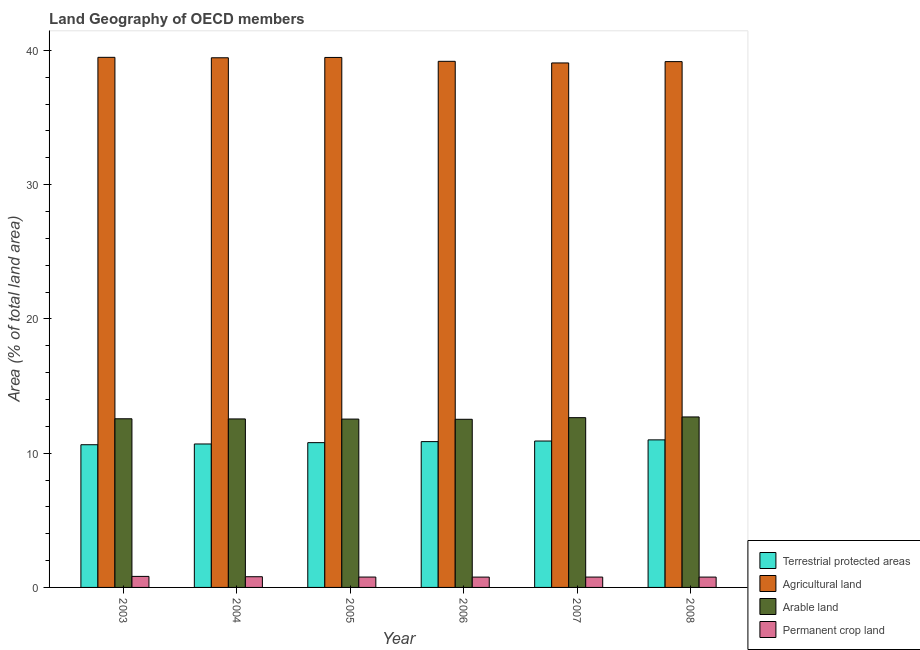Are the number of bars on each tick of the X-axis equal?
Provide a succinct answer. Yes. How many bars are there on the 6th tick from the right?
Provide a short and direct response. 4. What is the label of the 3rd group of bars from the left?
Your answer should be compact. 2005. What is the percentage of area under agricultural land in 2003?
Make the answer very short. 39.48. Across all years, what is the maximum percentage of area under permanent crop land?
Offer a very short reply. 0.82. Across all years, what is the minimum percentage of land under terrestrial protection?
Provide a short and direct response. 10.63. In which year was the percentage of land under terrestrial protection minimum?
Keep it short and to the point. 2003. What is the total percentage of area under arable land in the graph?
Keep it short and to the point. 75.51. What is the difference between the percentage of area under permanent crop land in 2006 and that in 2007?
Offer a very short reply. -0. What is the difference between the percentage of area under agricultural land in 2005 and the percentage of area under permanent crop land in 2003?
Your answer should be very brief. -0.01. What is the average percentage of area under agricultural land per year?
Offer a very short reply. 39.3. In the year 2005, what is the difference between the percentage of area under agricultural land and percentage of land under terrestrial protection?
Your answer should be compact. 0. What is the ratio of the percentage of area under agricultural land in 2003 to that in 2004?
Give a very brief answer. 1. Is the difference between the percentage of land under terrestrial protection in 2005 and 2007 greater than the difference between the percentage of area under arable land in 2005 and 2007?
Your response must be concise. No. What is the difference between the highest and the second highest percentage of area under permanent crop land?
Offer a very short reply. 0.02. What is the difference between the highest and the lowest percentage of land under terrestrial protection?
Your response must be concise. 0.36. Is it the case that in every year, the sum of the percentage of area under permanent crop land and percentage of area under arable land is greater than the sum of percentage of land under terrestrial protection and percentage of area under agricultural land?
Offer a very short reply. No. What does the 3rd bar from the left in 2003 represents?
Ensure brevity in your answer.  Arable land. What does the 4th bar from the right in 2005 represents?
Keep it short and to the point. Terrestrial protected areas. Where does the legend appear in the graph?
Provide a short and direct response. Bottom right. What is the title of the graph?
Provide a succinct answer. Land Geography of OECD members. Does "Methodology assessment" appear as one of the legend labels in the graph?
Provide a short and direct response. No. What is the label or title of the X-axis?
Offer a terse response. Year. What is the label or title of the Y-axis?
Your response must be concise. Area (% of total land area). What is the Area (% of total land area) of Terrestrial protected areas in 2003?
Make the answer very short. 10.63. What is the Area (% of total land area) in Agricultural land in 2003?
Offer a very short reply. 39.48. What is the Area (% of total land area) of Arable land in 2003?
Give a very brief answer. 12.56. What is the Area (% of total land area) of Permanent crop land in 2003?
Make the answer very short. 0.82. What is the Area (% of total land area) of Terrestrial protected areas in 2004?
Offer a very short reply. 10.68. What is the Area (% of total land area) of Agricultural land in 2004?
Ensure brevity in your answer.  39.45. What is the Area (% of total land area) in Arable land in 2004?
Offer a very short reply. 12.55. What is the Area (% of total land area) of Permanent crop land in 2004?
Offer a very short reply. 0.8. What is the Area (% of total land area) in Terrestrial protected areas in 2005?
Ensure brevity in your answer.  10.78. What is the Area (% of total land area) of Agricultural land in 2005?
Provide a short and direct response. 39.47. What is the Area (% of total land area) in Arable land in 2005?
Provide a short and direct response. 12.54. What is the Area (% of total land area) of Permanent crop land in 2005?
Provide a short and direct response. 0.77. What is the Area (% of total land area) of Terrestrial protected areas in 2006?
Your response must be concise. 10.86. What is the Area (% of total land area) of Agricultural land in 2006?
Give a very brief answer. 39.18. What is the Area (% of total land area) of Arable land in 2006?
Offer a very short reply. 12.52. What is the Area (% of total land area) in Permanent crop land in 2006?
Your answer should be compact. 0.77. What is the Area (% of total land area) in Terrestrial protected areas in 2007?
Offer a terse response. 10.9. What is the Area (% of total land area) of Agricultural land in 2007?
Your answer should be very brief. 39.06. What is the Area (% of total land area) in Arable land in 2007?
Your response must be concise. 12.64. What is the Area (% of total land area) of Permanent crop land in 2007?
Make the answer very short. 0.77. What is the Area (% of total land area) of Terrestrial protected areas in 2008?
Keep it short and to the point. 10.99. What is the Area (% of total land area) of Agricultural land in 2008?
Keep it short and to the point. 39.16. What is the Area (% of total land area) of Arable land in 2008?
Your answer should be compact. 12.7. What is the Area (% of total land area) of Permanent crop land in 2008?
Offer a very short reply. 0.77. Across all years, what is the maximum Area (% of total land area) in Terrestrial protected areas?
Keep it short and to the point. 10.99. Across all years, what is the maximum Area (% of total land area) of Agricultural land?
Provide a succinct answer. 39.48. Across all years, what is the maximum Area (% of total land area) in Arable land?
Give a very brief answer. 12.7. Across all years, what is the maximum Area (% of total land area) of Permanent crop land?
Give a very brief answer. 0.82. Across all years, what is the minimum Area (% of total land area) in Terrestrial protected areas?
Offer a terse response. 10.63. Across all years, what is the minimum Area (% of total land area) in Agricultural land?
Give a very brief answer. 39.06. Across all years, what is the minimum Area (% of total land area) of Arable land?
Your answer should be compact. 12.52. Across all years, what is the minimum Area (% of total land area) of Permanent crop land?
Provide a short and direct response. 0.77. What is the total Area (% of total land area) in Terrestrial protected areas in the graph?
Keep it short and to the point. 64.85. What is the total Area (% of total land area) of Agricultural land in the graph?
Ensure brevity in your answer.  235.81. What is the total Area (% of total land area) of Arable land in the graph?
Give a very brief answer. 75.51. What is the total Area (% of total land area) in Permanent crop land in the graph?
Keep it short and to the point. 4.7. What is the difference between the Area (% of total land area) in Terrestrial protected areas in 2003 and that in 2004?
Your response must be concise. -0.06. What is the difference between the Area (% of total land area) of Agricultural land in 2003 and that in 2004?
Provide a succinct answer. 0.03. What is the difference between the Area (% of total land area) in Arable land in 2003 and that in 2004?
Your answer should be compact. 0.01. What is the difference between the Area (% of total land area) of Permanent crop land in 2003 and that in 2004?
Offer a terse response. 0.02. What is the difference between the Area (% of total land area) of Terrestrial protected areas in 2003 and that in 2005?
Your answer should be compact. -0.16. What is the difference between the Area (% of total land area) of Agricultural land in 2003 and that in 2005?
Give a very brief answer. 0.01. What is the difference between the Area (% of total land area) in Arable land in 2003 and that in 2005?
Your answer should be very brief. 0.02. What is the difference between the Area (% of total land area) in Permanent crop land in 2003 and that in 2005?
Provide a succinct answer. 0.05. What is the difference between the Area (% of total land area) in Terrestrial protected areas in 2003 and that in 2006?
Give a very brief answer. -0.23. What is the difference between the Area (% of total land area) of Agricultural land in 2003 and that in 2006?
Your response must be concise. 0.3. What is the difference between the Area (% of total land area) of Arable land in 2003 and that in 2006?
Provide a succinct answer. 0.04. What is the difference between the Area (% of total land area) of Permanent crop land in 2003 and that in 2006?
Keep it short and to the point. 0.05. What is the difference between the Area (% of total land area) of Terrestrial protected areas in 2003 and that in 2007?
Provide a short and direct response. -0.28. What is the difference between the Area (% of total land area) of Agricultural land in 2003 and that in 2007?
Ensure brevity in your answer.  0.42. What is the difference between the Area (% of total land area) in Arable land in 2003 and that in 2007?
Make the answer very short. -0.08. What is the difference between the Area (% of total land area) in Permanent crop land in 2003 and that in 2007?
Offer a terse response. 0.05. What is the difference between the Area (% of total land area) in Terrestrial protected areas in 2003 and that in 2008?
Provide a succinct answer. -0.36. What is the difference between the Area (% of total land area) of Agricultural land in 2003 and that in 2008?
Your response must be concise. 0.32. What is the difference between the Area (% of total land area) of Arable land in 2003 and that in 2008?
Your answer should be very brief. -0.14. What is the difference between the Area (% of total land area) of Permanent crop land in 2003 and that in 2008?
Offer a very short reply. 0.05. What is the difference between the Area (% of total land area) of Terrestrial protected areas in 2004 and that in 2005?
Ensure brevity in your answer.  -0.1. What is the difference between the Area (% of total land area) of Agricultural land in 2004 and that in 2005?
Keep it short and to the point. -0.02. What is the difference between the Area (% of total land area) in Arable land in 2004 and that in 2005?
Provide a short and direct response. 0.01. What is the difference between the Area (% of total land area) of Permanent crop land in 2004 and that in 2005?
Your response must be concise. 0.02. What is the difference between the Area (% of total land area) of Terrestrial protected areas in 2004 and that in 2006?
Offer a terse response. -0.18. What is the difference between the Area (% of total land area) in Agricultural land in 2004 and that in 2006?
Make the answer very short. 0.26. What is the difference between the Area (% of total land area) of Arable land in 2004 and that in 2006?
Offer a very short reply. 0.03. What is the difference between the Area (% of total land area) of Permanent crop land in 2004 and that in 2006?
Your response must be concise. 0.03. What is the difference between the Area (% of total land area) of Terrestrial protected areas in 2004 and that in 2007?
Provide a succinct answer. -0.22. What is the difference between the Area (% of total land area) of Agricultural land in 2004 and that in 2007?
Make the answer very short. 0.38. What is the difference between the Area (% of total land area) in Arable land in 2004 and that in 2007?
Your response must be concise. -0.09. What is the difference between the Area (% of total land area) of Permanent crop land in 2004 and that in 2007?
Your answer should be very brief. 0.03. What is the difference between the Area (% of total land area) of Terrestrial protected areas in 2004 and that in 2008?
Offer a very short reply. -0.31. What is the difference between the Area (% of total land area) in Agricultural land in 2004 and that in 2008?
Give a very brief answer. 0.29. What is the difference between the Area (% of total land area) in Arable land in 2004 and that in 2008?
Give a very brief answer. -0.15. What is the difference between the Area (% of total land area) in Permanent crop land in 2004 and that in 2008?
Your answer should be very brief. 0.03. What is the difference between the Area (% of total land area) in Terrestrial protected areas in 2005 and that in 2006?
Provide a short and direct response. -0.08. What is the difference between the Area (% of total land area) of Agricultural land in 2005 and that in 2006?
Provide a succinct answer. 0.29. What is the difference between the Area (% of total land area) of Arable land in 2005 and that in 2006?
Offer a very short reply. 0.01. What is the difference between the Area (% of total land area) of Permanent crop land in 2005 and that in 2006?
Provide a short and direct response. 0. What is the difference between the Area (% of total land area) of Terrestrial protected areas in 2005 and that in 2007?
Keep it short and to the point. -0.12. What is the difference between the Area (% of total land area) in Agricultural land in 2005 and that in 2007?
Provide a succinct answer. 0.41. What is the difference between the Area (% of total land area) in Arable land in 2005 and that in 2007?
Make the answer very short. -0.11. What is the difference between the Area (% of total land area) of Permanent crop land in 2005 and that in 2007?
Give a very brief answer. 0. What is the difference between the Area (% of total land area) of Terrestrial protected areas in 2005 and that in 2008?
Your response must be concise. -0.21. What is the difference between the Area (% of total land area) in Agricultural land in 2005 and that in 2008?
Make the answer very short. 0.31. What is the difference between the Area (% of total land area) of Arable land in 2005 and that in 2008?
Ensure brevity in your answer.  -0.16. What is the difference between the Area (% of total land area) in Permanent crop land in 2005 and that in 2008?
Ensure brevity in your answer.  0. What is the difference between the Area (% of total land area) in Terrestrial protected areas in 2006 and that in 2007?
Your response must be concise. -0.04. What is the difference between the Area (% of total land area) of Agricultural land in 2006 and that in 2007?
Provide a succinct answer. 0.12. What is the difference between the Area (% of total land area) of Arable land in 2006 and that in 2007?
Your response must be concise. -0.12. What is the difference between the Area (% of total land area) in Permanent crop land in 2006 and that in 2007?
Your answer should be very brief. -0. What is the difference between the Area (% of total land area) of Terrestrial protected areas in 2006 and that in 2008?
Ensure brevity in your answer.  -0.13. What is the difference between the Area (% of total land area) of Agricultural land in 2006 and that in 2008?
Provide a succinct answer. 0.02. What is the difference between the Area (% of total land area) of Arable land in 2006 and that in 2008?
Your response must be concise. -0.17. What is the difference between the Area (% of total land area) in Permanent crop land in 2006 and that in 2008?
Your answer should be very brief. -0. What is the difference between the Area (% of total land area) of Terrestrial protected areas in 2007 and that in 2008?
Keep it short and to the point. -0.09. What is the difference between the Area (% of total land area) of Agricultural land in 2007 and that in 2008?
Provide a succinct answer. -0.1. What is the difference between the Area (% of total land area) of Arable land in 2007 and that in 2008?
Your answer should be very brief. -0.05. What is the difference between the Area (% of total land area) of Permanent crop land in 2007 and that in 2008?
Provide a short and direct response. 0. What is the difference between the Area (% of total land area) in Terrestrial protected areas in 2003 and the Area (% of total land area) in Agricultural land in 2004?
Make the answer very short. -28.82. What is the difference between the Area (% of total land area) of Terrestrial protected areas in 2003 and the Area (% of total land area) of Arable land in 2004?
Ensure brevity in your answer.  -1.92. What is the difference between the Area (% of total land area) in Terrestrial protected areas in 2003 and the Area (% of total land area) in Permanent crop land in 2004?
Offer a terse response. 9.83. What is the difference between the Area (% of total land area) in Agricultural land in 2003 and the Area (% of total land area) in Arable land in 2004?
Provide a succinct answer. 26.93. What is the difference between the Area (% of total land area) of Agricultural land in 2003 and the Area (% of total land area) of Permanent crop land in 2004?
Provide a short and direct response. 38.68. What is the difference between the Area (% of total land area) of Arable land in 2003 and the Area (% of total land area) of Permanent crop land in 2004?
Your answer should be compact. 11.76. What is the difference between the Area (% of total land area) of Terrestrial protected areas in 2003 and the Area (% of total land area) of Agricultural land in 2005?
Offer a terse response. -28.84. What is the difference between the Area (% of total land area) of Terrestrial protected areas in 2003 and the Area (% of total land area) of Arable land in 2005?
Your response must be concise. -1.91. What is the difference between the Area (% of total land area) in Terrestrial protected areas in 2003 and the Area (% of total land area) in Permanent crop land in 2005?
Provide a short and direct response. 9.86. What is the difference between the Area (% of total land area) in Agricultural land in 2003 and the Area (% of total land area) in Arable land in 2005?
Provide a short and direct response. 26.94. What is the difference between the Area (% of total land area) in Agricultural land in 2003 and the Area (% of total land area) in Permanent crop land in 2005?
Your response must be concise. 38.71. What is the difference between the Area (% of total land area) of Arable land in 2003 and the Area (% of total land area) of Permanent crop land in 2005?
Give a very brief answer. 11.79. What is the difference between the Area (% of total land area) in Terrestrial protected areas in 2003 and the Area (% of total land area) in Agricultural land in 2006?
Offer a very short reply. -28.56. What is the difference between the Area (% of total land area) in Terrestrial protected areas in 2003 and the Area (% of total land area) in Arable land in 2006?
Ensure brevity in your answer.  -1.9. What is the difference between the Area (% of total land area) in Terrestrial protected areas in 2003 and the Area (% of total land area) in Permanent crop land in 2006?
Ensure brevity in your answer.  9.86. What is the difference between the Area (% of total land area) in Agricultural land in 2003 and the Area (% of total land area) in Arable land in 2006?
Your answer should be very brief. 26.96. What is the difference between the Area (% of total land area) of Agricultural land in 2003 and the Area (% of total land area) of Permanent crop land in 2006?
Offer a terse response. 38.71. What is the difference between the Area (% of total land area) of Arable land in 2003 and the Area (% of total land area) of Permanent crop land in 2006?
Ensure brevity in your answer.  11.79. What is the difference between the Area (% of total land area) in Terrestrial protected areas in 2003 and the Area (% of total land area) in Agricultural land in 2007?
Keep it short and to the point. -28.43. What is the difference between the Area (% of total land area) in Terrestrial protected areas in 2003 and the Area (% of total land area) in Arable land in 2007?
Your answer should be compact. -2.02. What is the difference between the Area (% of total land area) in Terrestrial protected areas in 2003 and the Area (% of total land area) in Permanent crop land in 2007?
Keep it short and to the point. 9.86. What is the difference between the Area (% of total land area) of Agricultural land in 2003 and the Area (% of total land area) of Arable land in 2007?
Make the answer very short. 26.84. What is the difference between the Area (% of total land area) of Agricultural land in 2003 and the Area (% of total land area) of Permanent crop land in 2007?
Provide a short and direct response. 38.71. What is the difference between the Area (% of total land area) in Arable land in 2003 and the Area (% of total land area) in Permanent crop land in 2007?
Your answer should be very brief. 11.79. What is the difference between the Area (% of total land area) in Terrestrial protected areas in 2003 and the Area (% of total land area) in Agricultural land in 2008?
Offer a terse response. -28.53. What is the difference between the Area (% of total land area) in Terrestrial protected areas in 2003 and the Area (% of total land area) in Arable land in 2008?
Ensure brevity in your answer.  -2.07. What is the difference between the Area (% of total land area) of Terrestrial protected areas in 2003 and the Area (% of total land area) of Permanent crop land in 2008?
Make the answer very short. 9.86. What is the difference between the Area (% of total land area) of Agricultural land in 2003 and the Area (% of total land area) of Arable land in 2008?
Provide a succinct answer. 26.78. What is the difference between the Area (% of total land area) of Agricultural land in 2003 and the Area (% of total land area) of Permanent crop land in 2008?
Make the answer very short. 38.71. What is the difference between the Area (% of total land area) of Arable land in 2003 and the Area (% of total land area) of Permanent crop land in 2008?
Your response must be concise. 11.79. What is the difference between the Area (% of total land area) of Terrestrial protected areas in 2004 and the Area (% of total land area) of Agricultural land in 2005?
Keep it short and to the point. -28.79. What is the difference between the Area (% of total land area) of Terrestrial protected areas in 2004 and the Area (% of total land area) of Arable land in 2005?
Ensure brevity in your answer.  -1.85. What is the difference between the Area (% of total land area) of Terrestrial protected areas in 2004 and the Area (% of total land area) of Permanent crop land in 2005?
Give a very brief answer. 9.91. What is the difference between the Area (% of total land area) in Agricultural land in 2004 and the Area (% of total land area) in Arable land in 2005?
Your answer should be compact. 26.91. What is the difference between the Area (% of total land area) of Agricultural land in 2004 and the Area (% of total land area) of Permanent crop land in 2005?
Offer a terse response. 38.68. What is the difference between the Area (% of total land area) in Arable land in 2004 and the Area (% of total land area) in Permanent crop land in 2005?
Keep it short and to the point. 11.78. What is the difference between the Area (% of total land area) of Terrestrial protected areas in 2004 and the Area (% of total land area) of Agricultural land in 2006?
Offer a terse response. -28.5. What is the difference between the Area (% of total land area) in Terrestrial protected areas in 2004 and the Area (% of total land area) in Arable land in 2006?
Offer a very short reply. -1.84. What is the difference between the Area (% of total land area) in Terrestrial protected areas in 2004 and the Area (% of total land area) in Permanent crop land in 2006?
Give a very brief answer. 9.91. What is the difference between the Area (% of total land area) in Agricultural land in 2004 and the Area (% of total land area) in Arable land in 2006?
Your answer should be very brief. 26.92. What is the difference between the Area (% of total land area) of Agricultural land in 2004 and the Area (% of total land area) of Permanent crop land in 2006?
Your response must be concise. 38.68. What is the difference between the Area (% of total land area) of Arable land in 2004 and the Area (% of total land area) of Permanent crop land in 2006?
Your response must be concise. 11.78. What is the difference between the Area (% of total land area) of Terrestrial protected areas in 2004 and the Area (% of total land area) of Agricultural land in 2007?
Provide a short and direct response. -28.38. What is the difference between the Area (% of total land area) of Terrestrial protected areas in 2004 and the Area (% of total land area) of Arable land in 2007?
Ensure brevity in your answer.  -1.96. What is the difference between the Area (% of total land area) of Terrestrial protected areas in 2004 and the Area (% of total land area) of Permanent crop land in 2007?
Your answer should be compact. 9.91. What is the difference between the Area (% of total land area) in Agricultural land in 2004 and the Area (% of total land area) in Arable land in 2007?
Offer a terse response. 26.8. What is the difference between the Area (% of total land area) in Agricultural land in 2004 and the Area (% of total land area) in Permanent crop land in 2007?
Your response must be concise. 38.68. What is the difference between the Area (% of total land area) in Arable land in 2004 and the Area (% of total land area) in Permanent crop land in 2007?
Your answer should be compact. 11.78. What is the difference between the Area (% of total land area) of Terrestrial protected areas in 2004 and the Area (% of total land area) of Agricultural land in 2008?
Your answer should be compact. -28.48. What is the difference between the Area (% of total land area) in Terrestrial protected areas in 2004 and the Area (% of total land area) in Arable land in 2008?
Provide a short and direct response. -2.01. What is the difference between the Area (% of total land area) in Terrestrial protected areas in 2004 and the Area (% of total land area) in Permanent crop land in 2008?
Your answer should be very brief. 9.91. What is the difference between the Area (% of total land area) of Agricultural land in 2004 and the Area (% of total land area) of Arable land in 2008?
Provide a succinct answer. 26.75. What is the difference between the Area (% of total land area) in Agricultural land in 2004 and the Area (% of total land area) in Permanent crop land in 2008?
Offer a terse response. 38.68. What is the difference between the Area (% of total land area) of Arable land in 2004 and the Area (% of total land area) of Permanent crop land in 2008?
Offer a very short reply. 11.78. What is the difference between the Area (% of total land area) in Terrestrial protected areas in 2005 and the Area (% of total land area) in Agricultural land in 2006?
Make the answer very short. -28.4. What is the difference between the Area (% of total land area) of Terrestrial protected areas in 2005 and the Area (% of total land area) of Arable land in 2006?
Your response must be concise. -1.74. What is the difference between the Area (% of total land area) of Terrestrial protected areas in 2005 and the Area (% of total land area) of Permanent crop land in 2006?
Give a very brief answer. 10.01. What is the difference between the Area (% of total land area) of Agricultural land in 2005 and the Area (% of total land area) of Arable land in 2006?
Provide a short and direct response. 26.95. What is the difference between the Area (% of total land area) in Agricultural land in 2005 and the Area (% of total land area) in Permanent crop land in 2006?
Ensure brevity in your answer.  38.7. What is the difference between the Area (% of total land area) of Arable land in 2005 and the Area (% of total land area) of Permanent crop land in 2006?
Your response must be concise. 11.77. What is the difference between the Area (% of total land area) of Terrestrial protected areas in 2005 and the Area (% of total land area) of Agricultural land in 2007?
Offer a terse response. -28.28. What is the difference between the Area (% of total land area) of Terrestrial protected areas in 2005 and the Area (% of total land area) of Arable land in 2007?
Provide a succinct answer. -1.86. What is the difference between the Area (% of total land area) in Terrestrial protected areas in 2005 and the Area (% of total land area) in Permanent crop land in 2007?
Offer a terse response. 10.01. What is the difference between the Area (% of total land area) of Agricultural land in 2005 and the Area (% of total land area) of Arable land in 2007?
Your response must be concise. 26.83. What is the difference between the Area (% of total land area) in Agricultural land in 2005 and the Area (% of total land area) in Permanent crop land in 2007?
Give a very brief answer. 38.7. What is the difference between the Area (% of total land area) of Arable land in 2005 and the Area (% of total land area) of Permanent crop land in 2007?
Your answer should be compact. 11.77. What is the difference between the Area (% of total land area) in Terrestrial protected areas in 2005 and the Area (% of total land area) in Agricultural land in 2008?
Give a very brief answer. -28.38. What is the difference between the Area (% of total land area) in Terrestrial protected areas in 2005 and the Area (% of total land area) in Arable land in 2008?
Make the answer very short. -1.91. What is the difference between the Area (% of total land area) of Terrestrial protected areas in 2005 and the Area (% of total land area) of Permanent crop land in 2008?
Your response must be concise. 10.01. What is the difference between the Area (% of total land area) of Agricultural land in 2005 and the Area (% of total land area) of Arable land in 2008?
Offer a terse response. 26.77. What is the difference between the Area (% of total land area) in Agricultural land in 2005 and the Area (% of total land area) in Permanent crop land in 2008?
Keep it short and to the point. 38.7. What is the difference between the Area (% of total land area) of Arable land in 2005 and the Area (% of total land area) of Permanent crop land in 2008?
Your response must be concise. 11.77. What is the difference between the Area (% of total land area) of Terrestrial protected areas in 2006 and the Area (% of total land area) of Agricultural land in 2007?
Give a very brief answer. -28.2. What is the difference between the Area (% of total land area) of Terrestrial protected areas in 2006 and the Area (% of total land area) of Arable land in 2007?
Your response must be concise. -1.78. What is the difference between the Area (% of total land area) in Terrestrial protected areas in 2006 and the Area (% of total land area) in Permanent crop land in 2007?
Your answer should be compact. 10.09. What is the difference between the Area (% of total land area) in Agricultural land in 2006 and the Area (% of total land area) in Arable land in 2007?
Your answer should be very brief. 26.54. What is the difference between the Area (% of total land area) in Agricultural land in 2006 and the Area (% of total land area) in Permanent crop land in 2007?
Make the answer very short. 38.41. What is the difference between the Area (% of total land area) of Arable land in 2006 and the Area (% of total land area) of Permanent crop land in 2007?
Provide a succinct answer. 11.75. What is the difference between the Area (% of total land area) in Terrestrial protected areas in 2006 and the Area (% of total land area) in Agricultural land in 2008?
Make the answer very short. -28.3. What is the difference between the Area (% of total land area) of Terrestrial protected areas in 2006 and the Area (% of total land area) of Arable land in 2008?
Your response must be concise. -1.84. What is the difference between the Area (% of total land area) of Terrestrial protected areas in 2006 and the Area (% of total land area) of Permanent crop land in 2008?
Make the answer very short. 10.09. What is the difference between the Area (% of total land area) in Agricultural land in 2006 and the Area (% of total land area) in Arable land in 2008?
Your answer should be very brief. 26.49. What is the difference between the Area (% of total land area) in Agricultural land in 2006 and the Area (% of total land area) in Permanent crop land in 2008?
Give a very brief answer. 38.41. What is the difference between the Area (% of total land area) in Arable land in 2006 and the Area (% of total land area) in Permanent crop land in 2008?
Offer a very short reply. 11.75. What is the difference between the Area (% of total land area) in Terrestrial protected areas in 2007 and the Area (% of total land area) in Agricultural land in 2008?
Give a very brief answer. -28.26. What is the difference between the Area (% of total land area) in Terrestrial protected areas in 2007 and the Area (% of total land area) in Arable land in 2008?
Make the answer very short. -1.79. What is the difference between the Area (% of total land area) in Terrestrial protected areas in 2007 and the Area (% of total land area) in Permanent crop land in 2008?
Keep it short and to the point. 10.13. What is the difference between the Area (% of total land area) of Agricultural land in 2007 and the Area (% of total land area) of Arable land in 2008?
Provide a short and direct response. 26.37. What is the difference between the Area (% of total land area) of Agricultural land in 2007 and the Area (% of total land area) of Permanent crop land in 2008?
Give a very brief answer. 38.29. What is the difference between the Area (% of total land area) of Arable land in 2007 and the Area (% of total land area) of Permanent crop land in 2008?
Your answer should be very brief. 11.87. What is the average Area (% of total land area) of Terrestrial protected areas per year?
Offer a terse response. 10.81. What is the average Area (% of total land area) of Agricultural land per year?
Offer a terse response. 39.3. What is the average Area (% of total land area) in Arable land per year?
Keep it short and to the point. 12.59. What is the average Area (% of total land area) in Permanent crop land per year?
Your answer should be compact. 0.78. In the year 2003, what is the difference between the Area (% of total land area) in Terrestrial protected areas and Area (% of total land area) in Agricultural land?
Make the answer very short. -28.85. In the year 2003, what is the difference between the Area (% of total land area) in Terrestrial protected areas and Area (% of total land area) in Arable land?
Keep it short and to the point. -1.93. In the year 2003, what is the difference between the Area (% of total land area) of Terrestrial protected areas and Area (% of total land area) of Permanent crop land?
Make the answer very short. 9.81. In the year 2003, what is the difference between the Area (% of total land area) of Agricultural land and Area (% of total land area) of Arable land?
Offer a terse response. 26.92. In the year 2003, what is the difference between the Area (% of total land area) in Agricultural land and Area (% of total land area) in Permanent crop land?
Provide a succinct answer. 38.66. In the year 2003, what is the difference between the Area (% of total land area) in Arable land and Area (% of total land area) in Permanent crop land?
Provide a succinct answer. 11.74. In the year 2004, what is the difference between the Area (% of total land area) of Terrestrial protected areas and Area (% of total land area) of Agricultural land?
Keep it short and to the point. -28.76. In the year 2004, what is the difference between the Area (% of total land area) of Terrestrial protected areas and Area (% of total land area) of Arable land?
Ensure brevity in your answer.  -1.87. In the year 2004, what is the difference between the Area (% of total land area) in Terrestrial protected areas and Area (% of total land area) in Permanent crop land?
Make the answer very short. 9.89. In the year 2004, what is the difference between the Area (% of total land area) of Agricultural land and Area (% of total land area) of Arable land?
Offer a very short reply. 26.9. In the year 2004, what is the difference between the Area (% of total land area) in Agricultural land and Area (% of total land area) in Permanent crop land?
Your answer should be very brief. 38.65. In the year 2004, what is the difference between the Area (% of total land area) of Arable land and Area (% of total land area) of Permanent crop land?
Your response must be concise. 11.75. In the year 2005, what is the difference between the Area (% of total land area) in Terrestrial protected areas and Area (% of total land area) in Agricultural land?
Offer a very short reply. -28.69. In the year 2005, what is the difference between the Area (% of total land area) of Terrestrial protected areas and Area (% of total land area) of Arable land?
Make the answer very short. -1.75. In the year 2005, what is the difference between the Area (% of total land area) in Terrestrial protected areas and Area (% of total land area) in Permanent crop land?
Your response must be concise. 10.01. In the year 2005, what is the difference between the Area (% of total land area) in Agricultural land and Area (% of total land area) in Arable land?
Offer a terse response. 26.93. In the year 2005, what is the difference between the Area (% of total land area) in Agricultural land and Area (% of total land area) in Permanent crop land?
Keep it short and to the point. 38.7. In the year 2005, what is the difference between the Area (% of total land area) in Arable land and Area (% of total land area) in Permanent crop land?
Your answer should be compact. 11.77. In the year 2006, what is the difference between the Area (% of total land area) of Terrestrial protected areas and Area (% of total land area) of Agricultural land?
Provide a short and direct response. -28.32. In the year 2006, what is the difference between the Area (% of total land area) of Terrestrial protected areas and Area (% of total land area) of Arable land?
Provide a short and direct response. -1.66. In the year 2006, what is the difference between the Area (% of total land area) in Terrestrial protected areas and Area (% of total land area) in Permanent crop land?
Make the answer very short. 10.09. In the year 2006, what is the difference between the Area (% of total land area) in Agricultural land and Area (% of total land area) in Arable land?
Your response must be concise. 26.66. In the year 2006, what is the difference between the Area (% of total land area) in Agricultural land and Area (% of total land area) in Permanent crop land?
Your answer should be very brief. 38.42. In the year 2006, what is the difference between the Area (% of total land area) in Arable land and Area (% of total land area) in Permanent crop land?
Your response must be concise. 11.75. In the year 2007, what is the difference between the Area (% of total land area) in Terrestrial protected areas and Area (% of total land area) in Agricultural land?
Offer a terse response. -28.16. In the year 2007, what is the difference between the Area (% of total land area) in Terrestrial protected areas and Area (% of total land area) in Arable land?
Provide a short and direct response. -1.74. In the year 2007, what is the difference between the Area (% of total land area) of Terrestrial protected areas and Area (% of total land area) of Permanent crop land?
Give a very brief answer. 10.13. In the year 2007, what is the difference between the Area (% of total land area) in Agricultural land and Area (% of total land area) in Arable land?
Give a very brief answer. 26.42. In the year 2007, what is the difference between the Area (% of total land area) of Agricultural land and Area (% of total land area) of Permanent crop land?
Your answer should be very brief. 38.29. In the year 2007, what is the difference between the Area (% of total land area) of Arable land and Area (% of total land area) of Permanent crop land?
Offer a terse response. 11.87. In the year 2008, what is the difference between the Area (% of total land area) of Terrestrial protected areas and Area (% of total land area) of Agricultural land?
Provide a succinct answer. -28.17. In the year 2008, what is the difference between the Area (% of total land area) in Terrestrial protected areas and Area (% of total land area) in Arable land?
Provide a succinct answer. -1.71. In the year 2008, what is the difference between the Area (% of total land area) of Terrestrial protected areas and Area (% of total land area) of Permanent crop land?
Provide a succinct answer. 10.22. In the year 2008, what is the difference between the Area (% of total land area) in Agricultural land and Area (% of total land area) in Arable land?
Keep it short and to the point. 26.46. In the year 2008, what is the difference between the Area (% of total land area) of Agricultural land and Area (% of total land area) of Permanent crop land?
Give a very brief answer. 38.39. In the year 2008, what is the difference between the Area (% of total land area) in Arable land and Area (% of total land area) in Permanent crop land?
Keep it short and to the point. 11.93. What is the ratio of the Area (% of total land area) of Permanent crop land in 2003 to that in 2004?
Your response must be concise. 1.03. What is the ratio of the Area (% of total land area) of Terrestrial protected areas in 2003 to that in 2005?
Provide a short and direct response. 0.99. What is the ratio of the Area (% of total land area) in Agricultural land in 2003 to that in 2005?
Your answer should be compact. 1. What is the ratio of the Area (% of total land area) of Arable land in 2003 to that in 2005?
Your answer should be very brief. 1. What is the ratio of the Area (% of total land area) of Permanent crop land in 2003 to that in 2005?
Provide a succinct answer. 1.06. What is the ratio of the Area (% of total land area) of Terrestrial protected areas in 2003 to that in 2006?
Your answer should be compact. 0.98. What is the ratio of the Area (% of total land area) in Agricultural land in 2003 to that in 2006?
Keep it short and to the point. 1.01. What is the ratio of the Area (% of total land area) of Arable land in 2003 to that in 2006?
Ensure brevity in your answer.  1. What is the ratio of the Area (% of total land area) in Permanent crop land in 2003 to that in 2006?
Offer a terse response. 1.07. What is the ratio of the Area (% of total land area) of Terrestrial protected areas in 2003 to that in 2007?
Your response must be concise. 0.97. What is the ratio of the Area (% of total land area) in Agricultural land in 2003 to that in 2007?
Your answer should be very brief. 1.01. What is the ratio of the Area (% of total land area) of Arable land in 2003 to that in 2007?
Your response must be concise. 0.99. What is the ratio of the Area (% of total land area) in Permanent crop land in 2003 to that in 2007?
Keep it short and to the point. 1.06. What is the ratio of the Area (% of total land area) in Terrestrial protected areas in 2003 to that in 2008?
Keep it short and to the point. 0.97. What is the ratio of the Area (% of total land area) of Agricultural land in 2003 to that in 2008?
Your response must be concise. 1.01. What is the ratio of the Area (% of total land area) of Arable land in 2003 to that in 2008?
Make the answer very short. 0.99. What is the ratio of the Area (% of total land area) in Permanent crop land in 2003 to that in 2008?
Give a very brief answer. 1.07. What is the ratio of the Area (% of total land area) of Agricultural land in 2004 to that in 2005?
Offer a very short reply. 1. What is the ratio of the Area (% of total land area) of Arable land in 2004 to that in 2005?
Keep it short and to the point. 1. What is the ratio of the Area (% of total land area) of Permanent crop land in 2004 to that in 2005?
Give a very brief answer. 1.03. What is the ratio of the Area (% of total land area) in Terrestrial protected areas in 2004 to that in 2006?
Ensure brevity in your answer.  0.98. What is the ratio of the Area (% of total land area) in Agricultural land in 2004 to that in 2006?
Your answer should be compact. 1.01. What is the ratio of the Area (% of total land area) of Arable land in 2004 to that in 2006?
Keep it short and to the point. 1. What is the ratio of the Area (% of total land area) of Permanent crop land in 2004 to that in 2006?
Make the answer very short. 1.04. What is the ratio of the Area (% of total land area) in Terrestrial protected areas in 2004 to that in 2007?
Provide a succinct answer. 0.98. What is the ratio of the Area (% of total land area) of Agricultural land in 2004 to that in 2007?
Offer a very short reply. 1.01. What is the ratio of the Area (% of total land area) of Arable land in 2004 to that in 2007?
Provide a succinct answer. 0.99. What is the ratio of the Area (% of total land area) in Permanent crop land in 2004 to that in 2007?
Your response must be concise. 1.03. What is the ratio of the Area (% of total land area) in Terrestrial protected areas in 2004 to that in 2008?
Your answer should be very brief. 0.97. What is the ratio of the Area (% of total land area) of Agricultural land in 2004 to that in 2008?
Your response must be concise. 1.01. What is the ratio of the Area (% of total land area) of Arable land in 2004 to that in 2008?
Your answer should be compact. 0.99. What is the ratio of the Area (% of total land area) of Permanent crop land in 2004 to that in 2008?
Offer a terse response. 1.04. What is the ratio of the Area (% of total land area) of Agricultural land in 2005 to that in 2006?
Your answer should be very brief. 1.01. What is the ratio of the Area (% of total land area) in Agricultural land in 2005 to that in 2007?
Provide a short and direct response. 1.01. What is the ratio of the Area (% of total land area) in Permanent crop land in 2005 to that in 2007?
Provide a short and direct response. 1. What is the ratio of the Area (% of total land area) of Terrestrial protected areas in 2005 to that in 2008?
Keep it short and to the point. 0.98. What is the ratio of the Area (% of total land area) of Agricultural land in 2005 to that in 2008?
Your answer should be very brief. 1.01. What is the ratio of the Area (% of total land area) of Arable land in 2005 to that in 2008?
Your answer should be very brief. 0.99. What is the ratio of the Area (% of total land area) in Agricultural land in 2006 to that in 2007?
Your answer should be very brief. 1. What is the ratio of the Area (% of total land area) in Arable land in 2006 to that in 2008?
Provide a short and direct response. 0.99. What is the ratio of the Area (% of total land area) of Permanent crop land in 2006 to that in 2008?
Your answer should be compact. 1. What is the ratio of the Area (% of total land area) in Agricultural land in 2007 to that in 2008?
Your response must be concise. 1. What is the ratio of the Area (% of total land area) of Arable land in 2007 to that in 2008?
Ensure brevity in your answer.  1. What is the difference between the highest and the second highest Area (% of total land area) of Terrestrial protected areas?
Give a very brief answer. 0.09. What is the difference between the highest and the second highest Area (% of total land area) in Agricultural land?
Your answer should be compact. 0.01. What is the difference between the highest and the second highest Area (% of total land area) of Arable land?
Provide a short and direct response. 0.05. What is the difference between the highest and the second highest Area (% of total land area) of Permanent crop land?
Offer a terse response. 0.02. What is the difference between the highest and the lowest Area (% of total land area) in Terrestrial protected areas?
Your response must be concise. 0.36. What is the difference between the highest and the lowest Area (% of total land area) of Agricultural land?
Ensure brevity in your answer.  0.42. What is the difference between the highest and the lowest Area (% of total land area) of Arable land?
Provide a succinct answer. 0.17. What is the difference between the highest and the lowest Area (% of total land area) of Permanent crop land?
Provide a succinct answer. 0.05. 